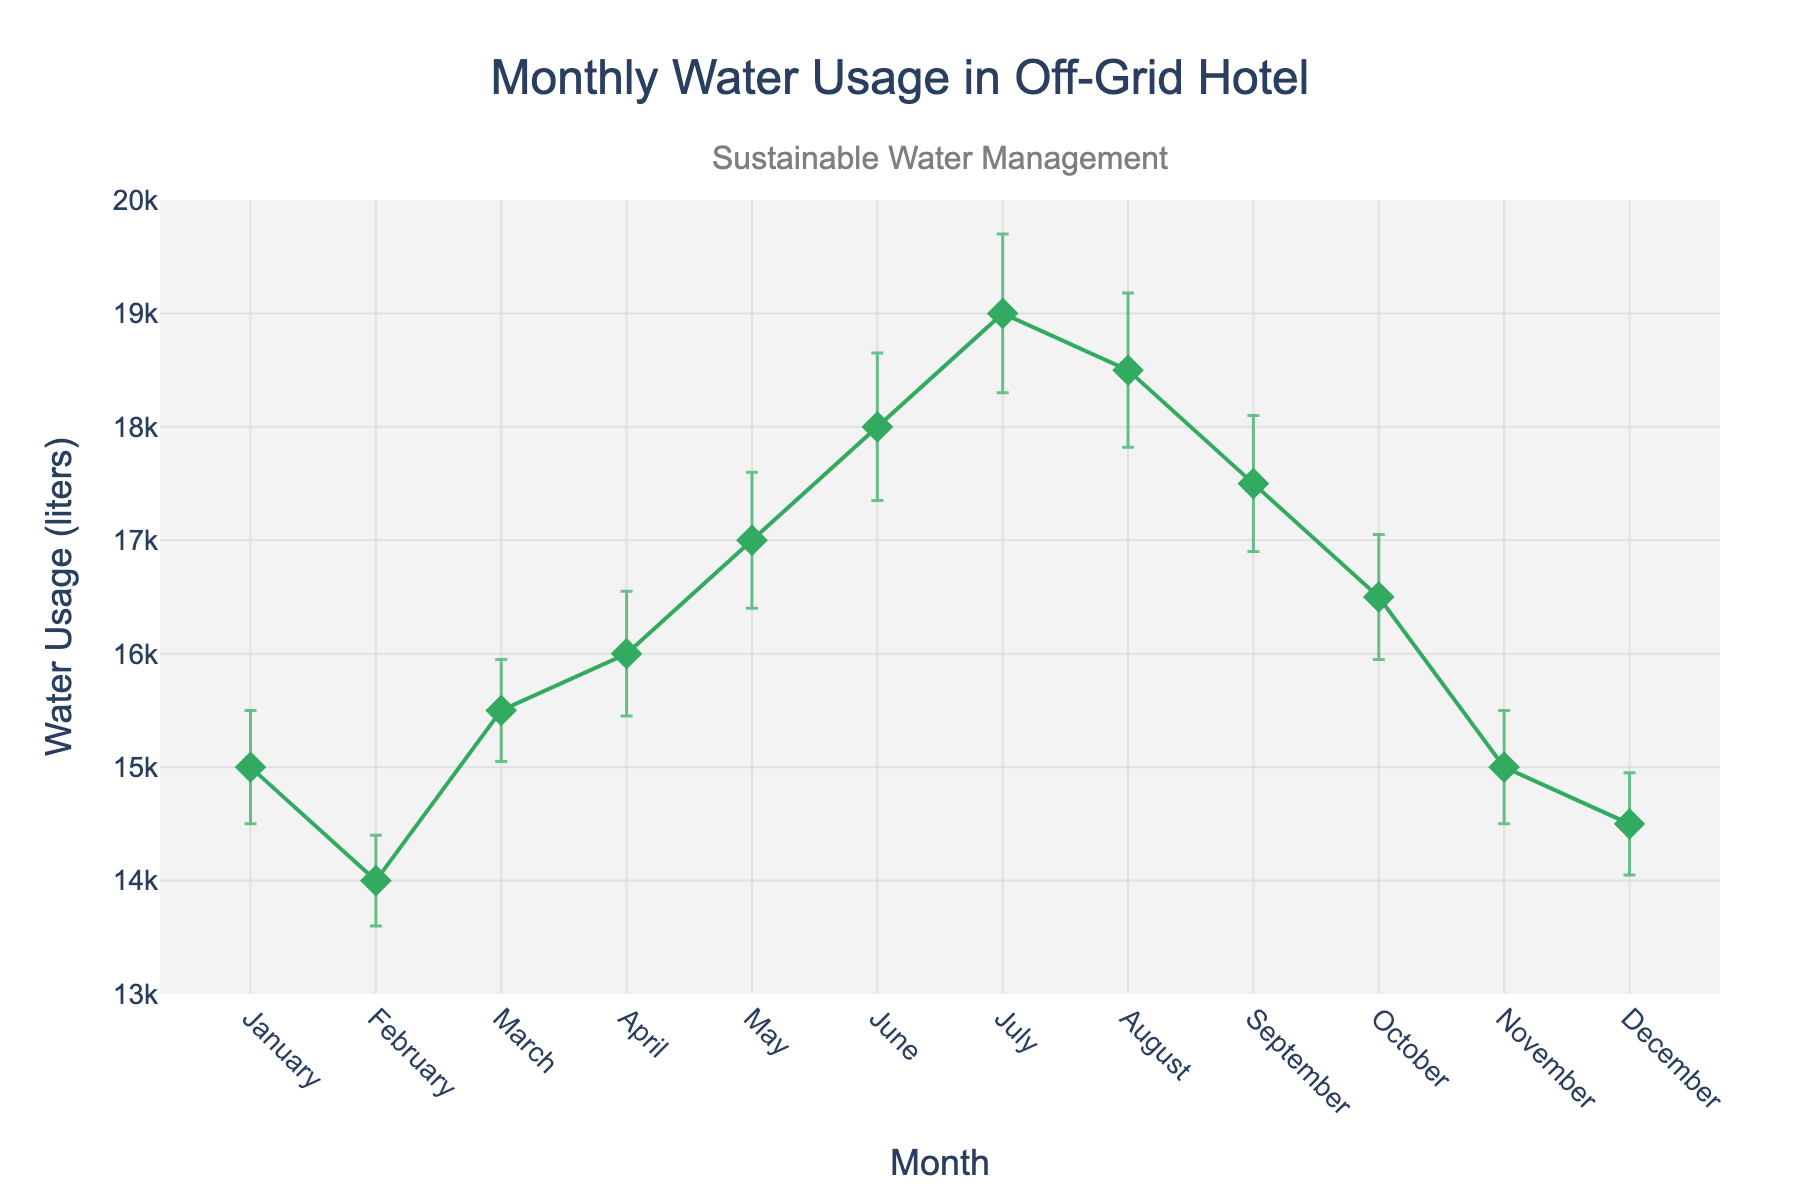what is the title of the plot? The title of the plot is usually bolded and positioned at the top of the figure. By looking at the figure, you can see the text "Monthly Water Usage in Off-Grid Hotel".
Answer: Monthly Water Usage in Off-Grid Hotel What is the mean water usage in June? To find the mean water usage in June, locate the June data point on the plot. The figure shows that the mean water usage for June is 18,000 liters.
Answer: 18,000 liters Which month has the highest mean water usage? To determine which month has the highest mean water usage, look for the peak point in the plot. The highest point corresponds to July with a mean water usage of 19,000 liters.
Answer: July What is the error range for water usage in August? The error range is given by the error bars. For August, the mean is 18,500 liters, and the error is ±680 liters. Therefore, the range is from 18,500 - 680 to 18,500 + 680 liters.
Answer: 17,820 to 19,180 liters How does the mean water usage in April compare to the mean water usage in October? Compare the points for April and October. April's mean is 16,000 liters and October's mean is 16,500 liters. This indicates that April's usage is 500 liters less than October's.
Answer: April's usage is less by 500 liters What is the average mean water usage for the first quarter (January to March)? Calculate the average by summing the mean usages for January, February, and March, then divide by 3: (15,000 + 14,000 + 15,500) / 3 = 44,500 / 3.
Answer: 14,833.33 liters Which months have a mean water usage between 15,000 and 16,000 liters? Identify months whose means fall within this range. The months are January (15,000), March (15,500), April (16,000), October (16,500), and November (15,000).
Answer: January, March, April, October, November What is the total error value for March and June combined? Add the error values for March and June: 450 liters (March) + 650 liters (June) = 1,100 liters.
Answer: 1,100 liters Which month experienced the smallest error in mean water usage? Identify the month with the smallest error bar. February has the smallest error of 400 liters.
Answer: February How does the water usage trend change from May to August? Analyze the points from May to August. May (17,000 liters) to June (18,000 liters) shows an increase, July peaks at 19,000 liters, and August decreases slightly to 18,500 liters.
Answer: It increases from May to July, then decreases in August 